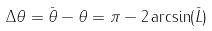Convert formula to latex. <formula><loc_0><loc_0><loc_500><loc_500>\Delta \theta = \bar { \theta } - \theta = \pi - 2 \arcsin ( { \bar { L } } )</formula> 